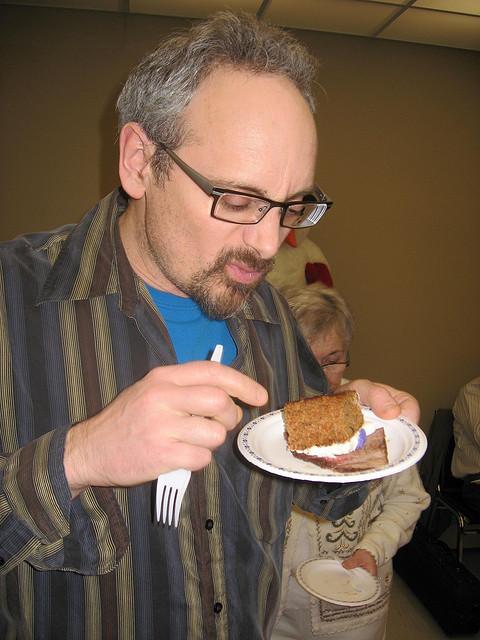Is everyone standing in this picture?
Be succinct. No. Is this man enjoying his food?
Quick response, please. No. What is this person eating?
Be succinct. Cake. 